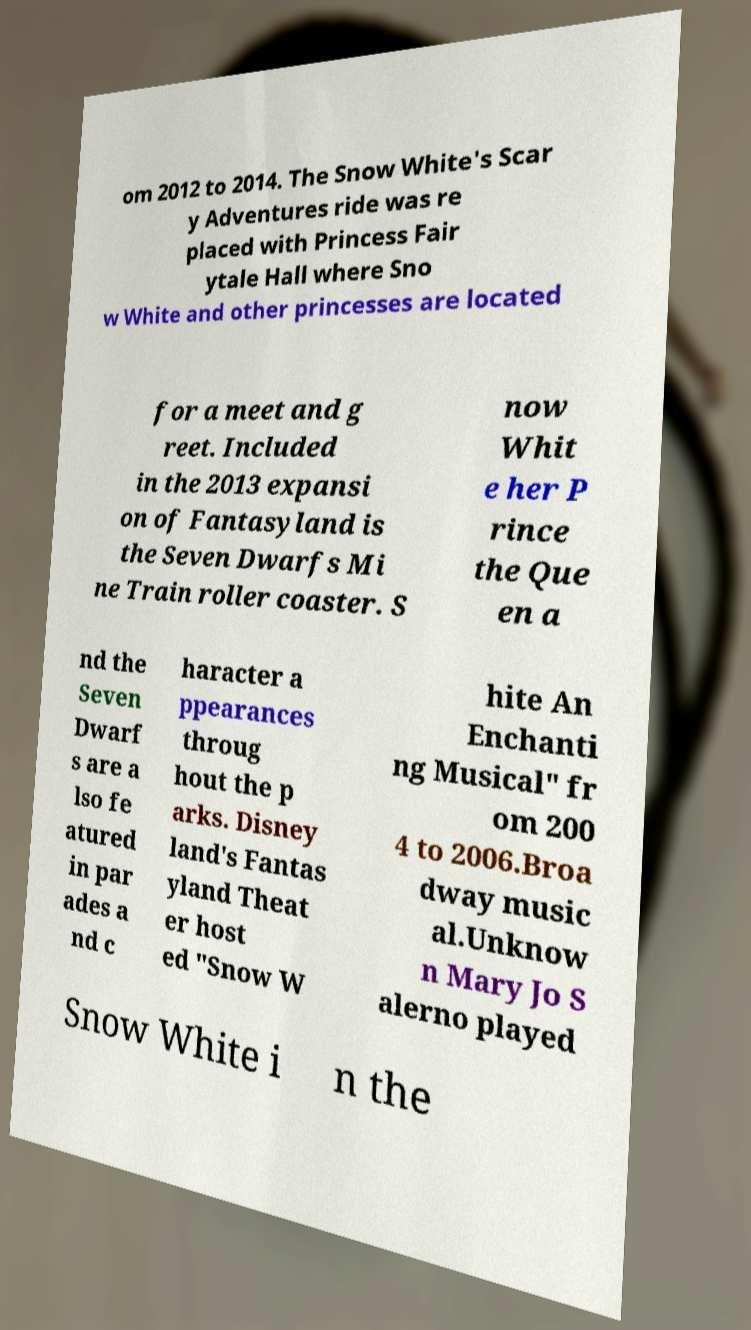Can you accurately transcribe the text from the provided image for me? om 2012 to 2014. The Snow White's Scar y Adventures ride was re placed with Princess Fair ytale Hall where Sno w White and other princesses are located for a meet and g reet. Included in the 2013 expansi on of Fantasyland is the Seven Dwarfs Mi ne Train roller coaster. S now Whit e her P rince the Que en a nd the Seven Dwarf s are a lso fe atured in par ades a nd c haracter a ppearances throug hout the p arks. Disney land's Fantas yland Theat er host ed "Snow W hite An Enchanti ng Musical" fr om 200 4 to 2006.Broa dway music al.Unknow n Mary Jo S alerno played Snow White i n the 